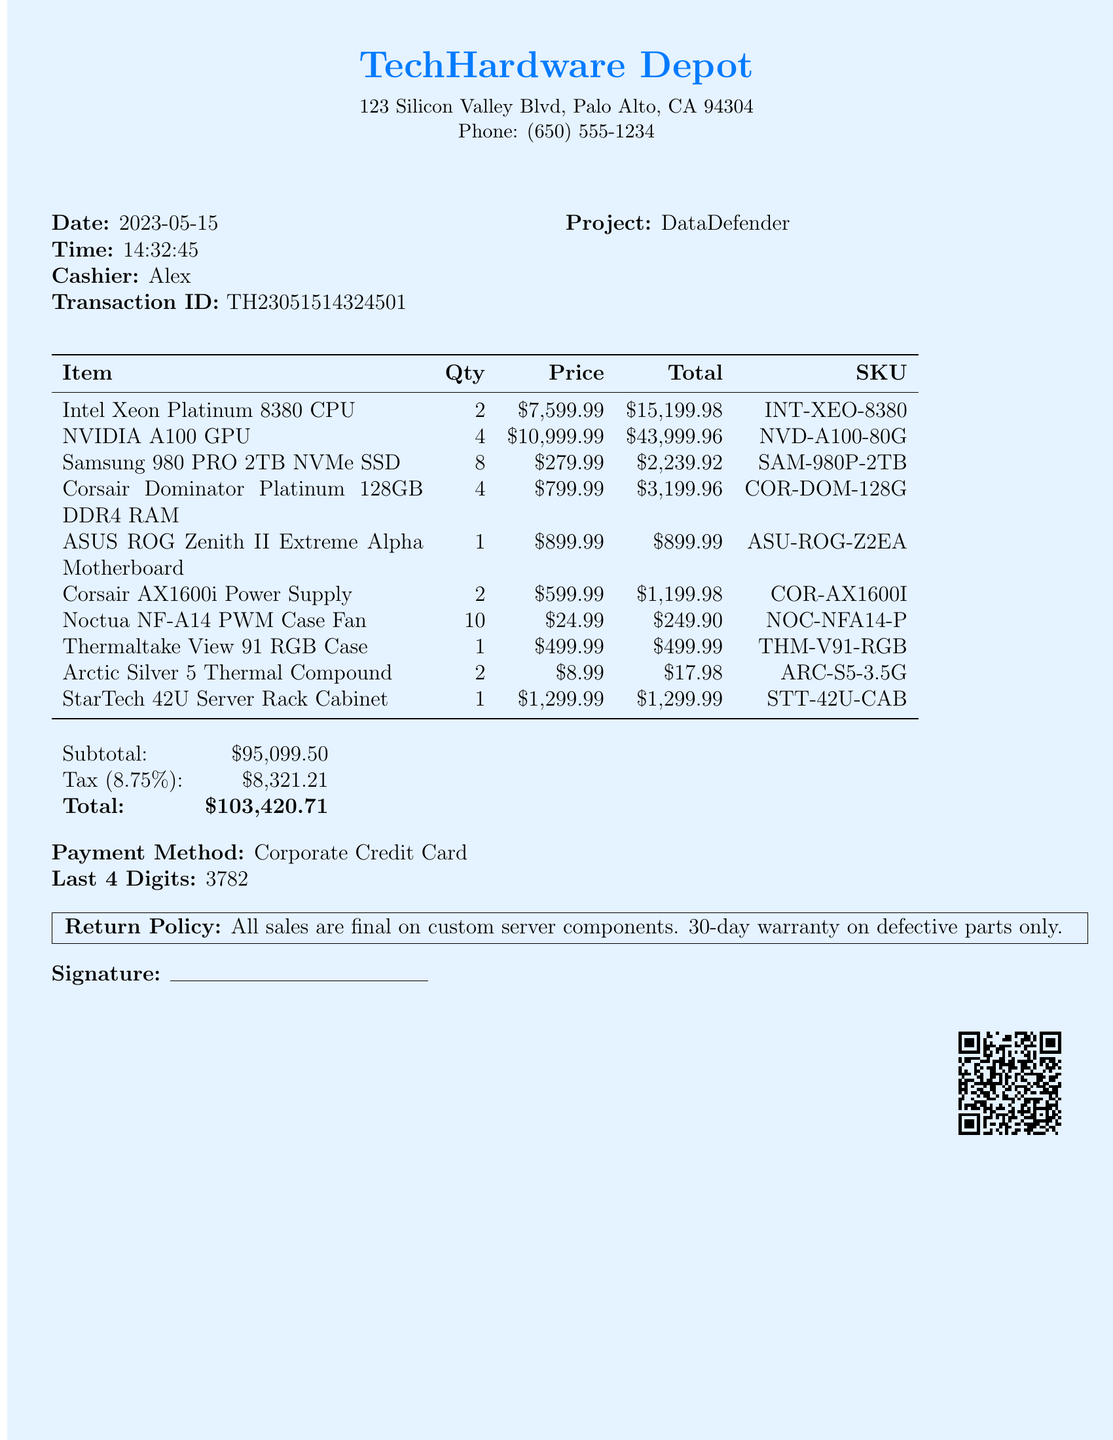What is the store name? The store name is mentioned prominently at the top of the document, which is TechHardware Depot.
Answer: TechHardware Depot What date was the receipt issued? The date is clearly stated in the receipt document as the date of purchase, which is 2023-05-15.
Answer: 2023-05-15 Who was the cashier for this transaction? The cashier's name is provided in the receipt, which is Alex.
Answer: Alex How many NVIDIA A100 GPUs were purchased? The receipt details the number of items purchased, which states that 4 NVIDIA A100 GPUs were bought.
Answer: 4 What is the total amount after tax? The total amount is computed after adding tax to the subtotal, which is 103420.71.
Answer: 103420.71 What is the return policy for custom server components? The receipt includes specific information on the return policy stating that all sales are final on custom server components.
Answer: All sales are final on custom server components What is the quantity of Noctua NF-A14 PWM Case Fans bought? The document lists the quantity specifically for Noctua NF-A14 PWM Case Fans, which is 10.
Answer: 10 What was the payment method used? The payment method is indicated in the document as Corporate Credit Card.
Answer: Corporate Credit Card What is the project codename mentioned in the notes? The project codename for the custom server build is highlighted in the notes section of the receipt as DataDefender.
Answer: DataDefender 